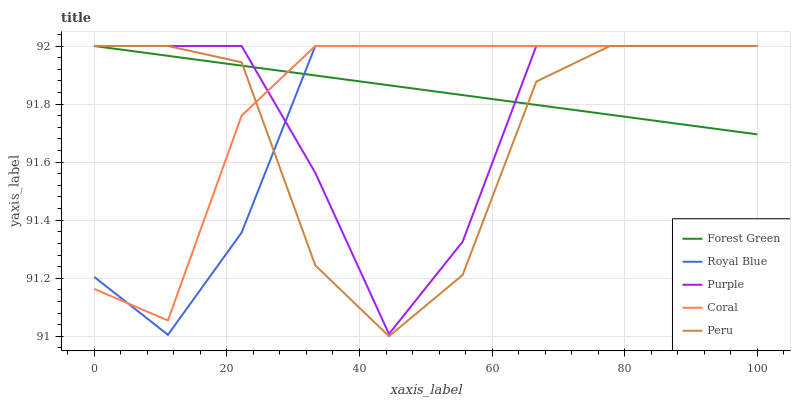Does Peru have the minimum area under the curve?
Answer yes or no. Yes. Does Forest Green have the maximum area under the curve?
Answer yes or no. Yes. Does Royal Blue have the minimum area under the curve?
Answer yes or no. No. Does Royal Blue have the maximum area under the curve?
Answer yes or no. No. Is Forest Green the smoothest?
Answer yes or no. Yes. Is Peru the roughest?
Answer yes or no. Yes. Is Royal Blue the smoothest?
Answer yes or no. No. Is Royal Blue the roughest?
Answer yes or no. No. Does Royal Blue have the lowest value?
Answer yes or no. No. Does Peru have the highest value?
Answer yes or no. Yes. Does Forest Green intersect Coral?
Answer yes or no. Yes. Is Forest Green less than Coral?
Answer yes or no. No. Is Forest Green greater than Coral?
Answer yes or no. No. 